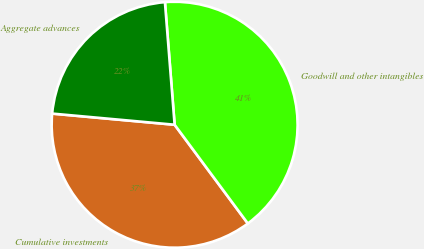Convert chart. <chart><loc_0><loc_0><loc_500><loc_500><pie_chart><fcel>Cumulative investments<fcel>Goodwill and other intangibles<fcel>Aggregate advances<nl><fcel>36.6%<fcel>41.1%<fcel>22.3%<nl></chart> 